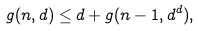Convert formula to latex. <formula><loc_0><loc_0><loc_500><loc_500>g ( n , d ) \leq d + g ( n - 1 , d ^ { d } ) ,</formula> 